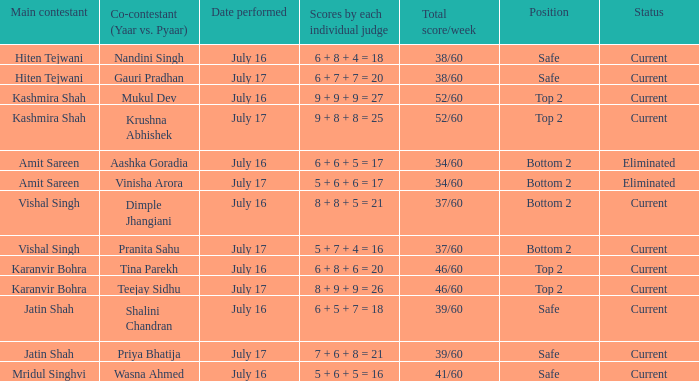Who performed with Tina Parekh? Karanvir Bohra. 